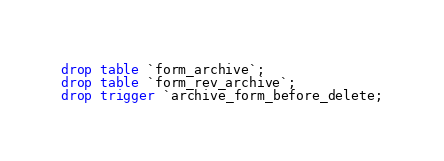<code> <loc_0><loc_0><loc_500><loc_500><_SQL_>drop table `form_archive`;
drop table `form_rev_archive`;
drop trigger `archive_form_before_delete;
</code> 